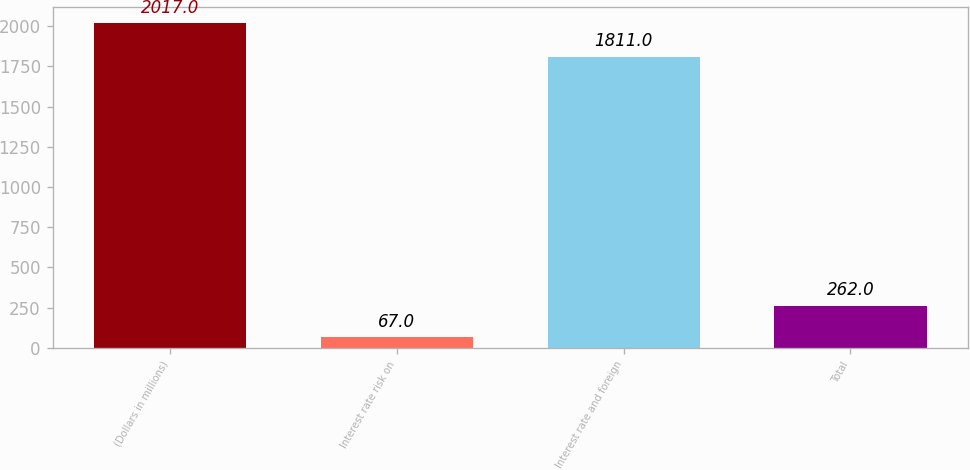Convert chart. <chart><loc_0><loc_0><loc_500><loc_500><bar_chart><fcel>(Dollars in millions)<fcel>Interest rate risk on<fcel>Interest rate and foreign<fcel>Total<nl><fcel>2017<fcel>67<fcel>1811<fcel>262<nl></chart> 